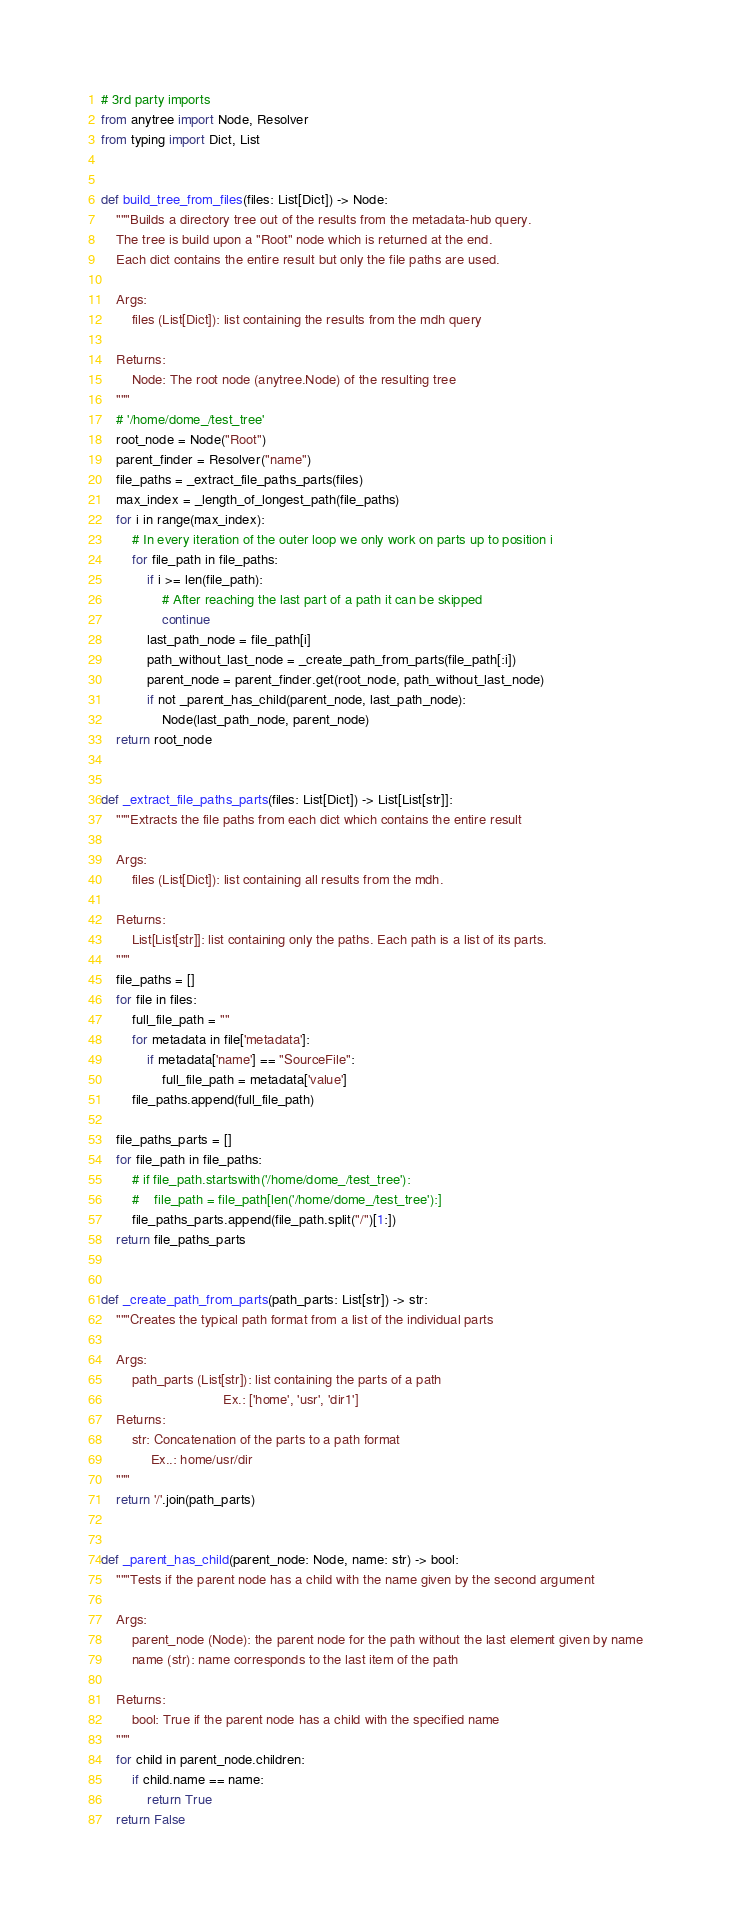<code> <loc_0><loc_0><loc_500><loc_500><_Python_># 3rd party imports
from anytree import Node, Resolver
from typing import Dict, List


def build_tree_from_files(files: List[Dict]) -> Node:
    """Builds a directory tree out of the results from the metadata-hub query.
    The tree is build upon a "Root" node which is returned at the end.
    Each dict contains the entire result but only the file paths are used.

    Args:
        files (List[Dict]): list containing the results from the mdh query

    Returns:
        Node: The root node (anytree.Node) of the resulting tree
    """
    # '/home/dome_/test_tree'
    root_node = Node("Root")
    parent_finder = Resolver("name")
    file_paths = _extract_file_paths_parts(files)
    max_index = _length_of_longest_path(file_paths)
    for i in range(max_index):
        # In every iteration of the outer loop we only work on parts up to position i
        for file_path in file_paths:
            if i >= len(file_path):
                # After reaching the last part of a path it can be skipped
                continue
            last_path_node = file_path[i]
            path_without_last_node = _create_path_from_parts(file_path[:i])
            parent_node = parent_finder.get(root_node, path_without_last_node)
            if not _parent_has_child(parent_node, last_path_node):
                Node(last_path_node, parent_node)
    return root_node


def _extract_file_paths_parts(files: List[Dict]) -> List[List[str]]:
    """Extracts the file paths from each dict which contains the entire result

    Args:
        files (List[Dict]): list containing all results from the mdh.

    Returns:
        List[List[str]]: list containing only the paths. Each path is a list of its parts.
    """
    file_paths = []
    for file in files:
        full_file_path = ""
        for metadata in file['metadata']:
            if metadata['name'] == "SourceFile":
                full_file_path = metadata['value']
        file_paths.append(full_file_path)

    file_paths_parts = []
    for file_path in file_paths:
        # if file_path.startswith('/home/dome_/test_tree'):
        #    file_path = file_path[len('/home/dome_/test_tree'):]
        file_paths_parts.append(file_path.split("/")[1:])
    return file_paths_parts


def _create_path_from_parts(path_parts: List[str]) -> str:
    """Creates the typical path format from a list of the individual parts

    Args:
        path_parts (List[str]): list containing the parts of a path
                                Ex.: ['home', 'usr', 'dir1']
    Returns:
        str: Concatenation of the parts to a path format
             Ex..: home/usr/dir
    """
    return '/'.join(path_parts)


def _parent_has_child(parent_node: Node, name: str) -> bool:
    """Tests if the parent node has a child with the name given by the second argument

    Args:
        parent_node (Node): the parent node for the path without the last element given by name
        name (str): name corresponds to the last item of the path

    Returns:
        bool: True if the parent node has a child with the specified name
    """
    for child in parent_node.children:
        if child.name == name:
            return True
    return False

</code> 